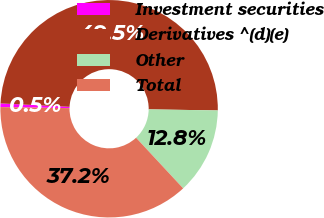Convert chart to OTSL. <chart><loc_0><loc_0><loc_500><loc_500><pie_chart><fcel>Investment securities<fcel>Derivatives ^(d)(e)<fcel>Other<fcel>Total<nl><fcel>0.54%<fcel>49.46%<fcel>12.83%<fcel>37.17%<nl></chart> 